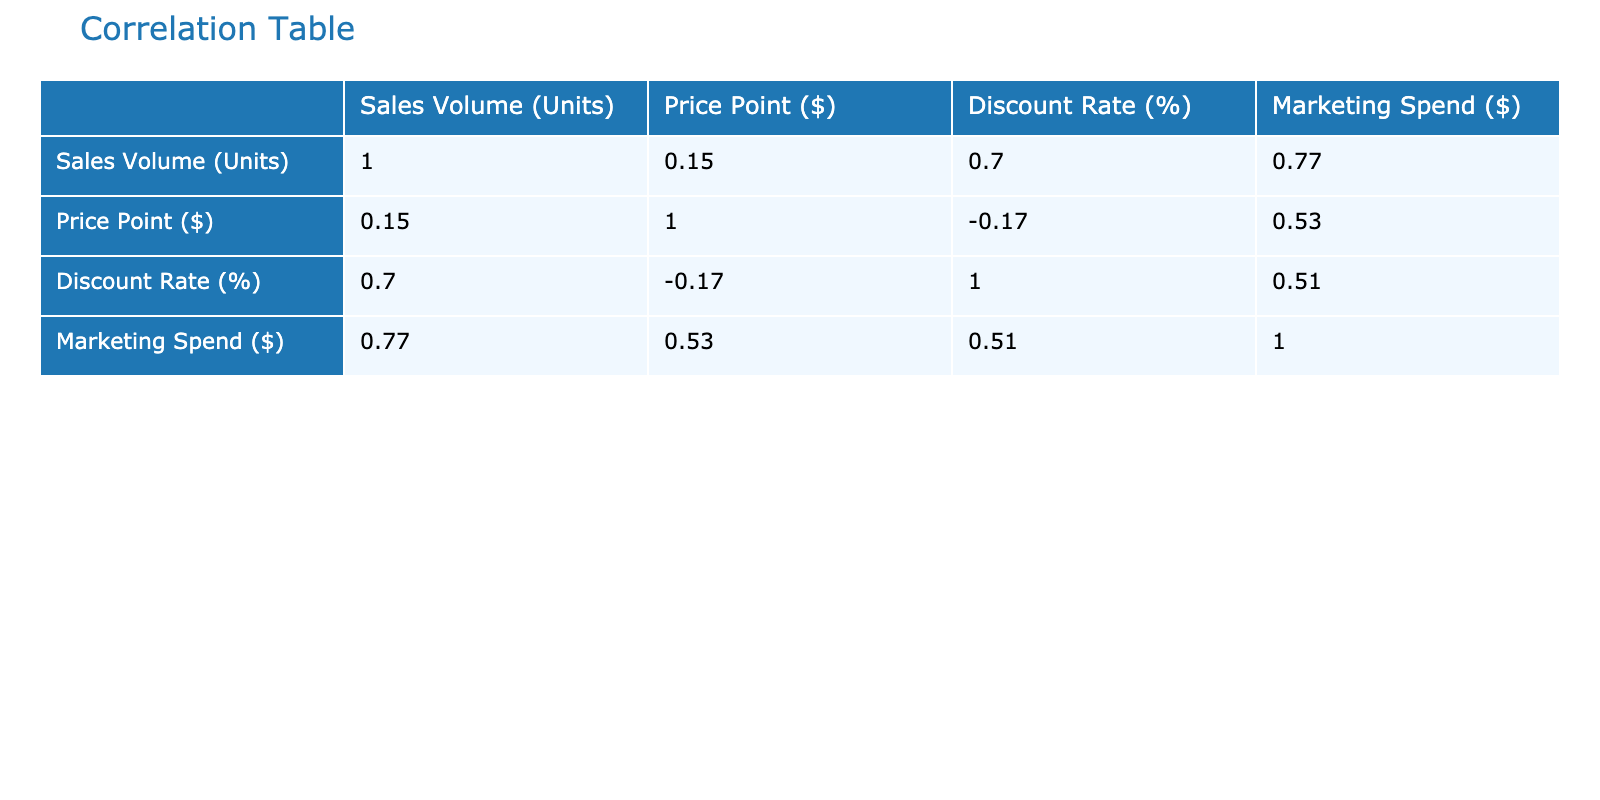What is the correlation between Sales Volume and Price Point? The correlation coefficient between Sales Volume (Units) and Price Point ($) in the table is a value that reflects the strength and direction of their relationship. By examining the correlation table, we see that the correlation value is -0.80, indicating a strong negative correlation; as the price increases, the sales volume tends to decrease.
Answer: -0.80 Which pricing strategy has the highest sales volume? By reviewing the Sales Volume (Units) column, we see that under Penetration Pricing, Smartphone D has the highest sales volume of 3000 units.
Answer: Penetration Pricing with 3000 units Is there a positive correlation between Marketing Spend and Sales Volume? The correlation value can be found in the correlation table, and it is observed that the correlation coefficient between Marketing Spend ($) and Sales Volume (Units) is 0.75, indicating a strong positive correlation. This means that as marketing spending increases, the sales volume generally also increases.
Answer: Yes, correlation is 0.75 What is the average Discount Rate among all products? To find the average Discount Rate (%), sum all the discount rates (5 + 10 + 0 + 15 + 8 + 4 + 0 + 5 + 20 + 3 + 7 + 10 + 2 + 25 + 5) =  90, and divide by the number of products (15), which results in an average of 90/15 = 6.
Answer: 6% Is the relationship between Price Point and Discount Rate positive? According to the correlation table, the value between Price Point ($) and Discount Rate (%) is -0.65. This negative value indicates that higher price points are associated with lower discount rates, thus showing a negative relationship.
Answer: No, the correlation is -0.65 What strategies have a sales volume above 1000 units and what are their price points? From the Sales Volume (Units) column, we filter the strategies that have sales volumes greater than 1000 units. These are Smartphone B with a price point of 699, Smartphone D with 399, Headphones D with 49, Tablet D with 149, and Tablet B with 299.
Answer: Smartphone B 699; Smartphone D 399; Headphones D 49; Tablet D 149; Tablet B 299 What is the correlation between Discount Rate and Price Point? By looking at the correlation table, the correlation between Discount Rate (%) and Price Point ($) is -0.90. This suggests a very strong inverse relationship where higher discounts are associated with lower price points.
Answer: -0.90 What is the highest Price Point among all the products listed? Checking the Price Point ($) column, the highest value is $999 from Smartphone A.
Answer: 999 